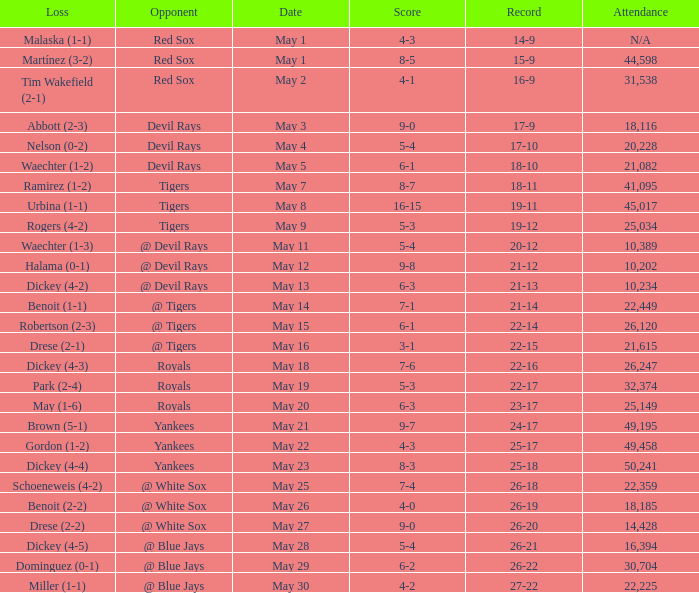What was the score of the game that had a loss of Drese (2-2)? 9-0. 